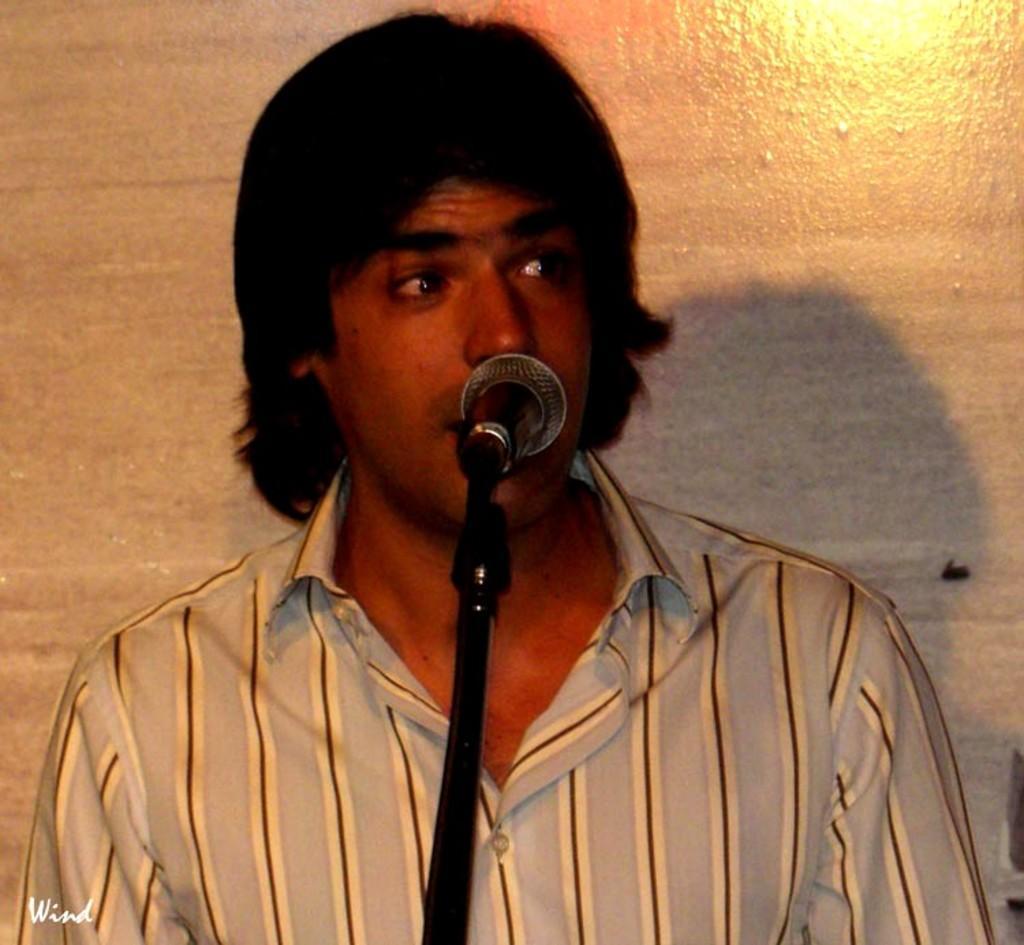How would you summarize this image in a sentence or two? In this image we can see there is a man and he is talking about something on the mike. 